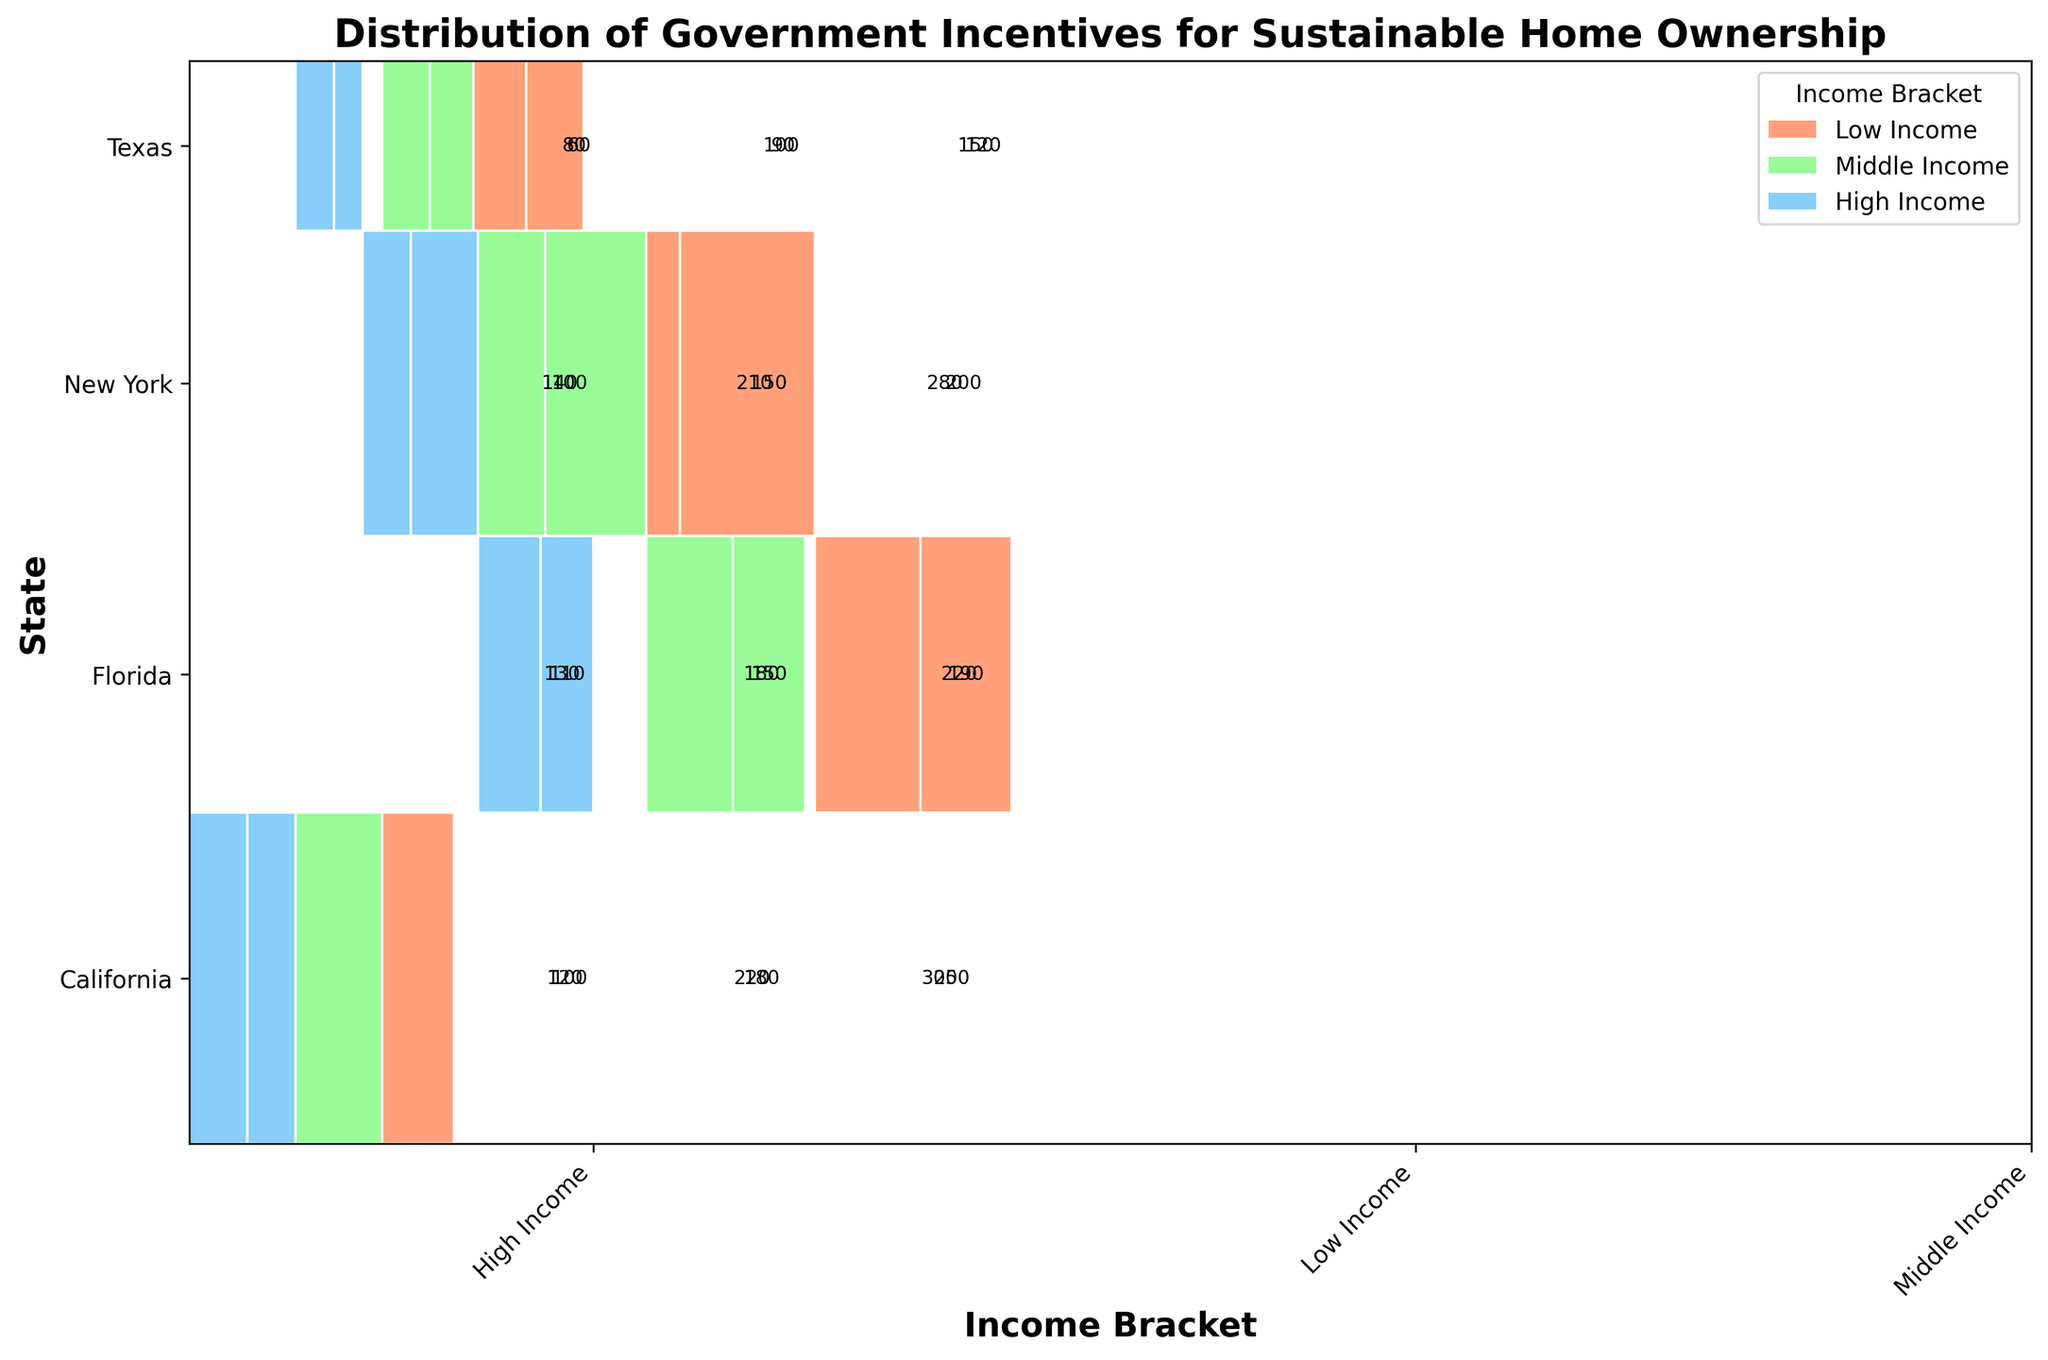What is the title of the plot? The title is typically located at the top of the plot. It is designed to give a brief description of what the chart represents.
Answer: Distribution of Government Incentives for Sustainable Home Ownership Which state has the highest total count of incentives? Look at the y-axis labels and find the state with the largest overall area. California's section is the highest.
Answer: California Which income bracket receives the most incentives in New York? Within New York's section on the plot, locate the largest area corresponding to each income bracket.
Answer: Low Income How does the count of Solar Tax Credits for Low Income in California compare to Middle Income in California? Observe the size of the rectangles within California's section for each income bracket. The Low Income section has a larger area than the Middle Income section.
Answer: Higher for Low Income What's the total count of incentives for Low Income in Texas? Sum the counts for Wind Power Rebate and Geothermal Incentive under Low Income in Texas. 150 + 120.
Answer: 270 Do Low Income households in Florida receive more or less Water Conservation Rebates than High Income households? Compare the areas of the rectangles representing Low Income and High Income within Florida's section for Water Conservation Rebates.
Answer: More Which state has the least diversity in incentive types? Check for a state with the fewest different colors (representing unique incentive types): Texas has only two types.
Answer: Texas How many types of incentives are provided to Middle Income earners in New York? Identify all the color rectangles within New York under the Middle Income label. There are two types: Green Roof Subsidy and Energy Star Appliance Rebate.
Answer: 2 What is the overall visual appearance of High Income incentives compared to Low Income incentives across all states? Notice the relative areas: High Income areas are generally smaller compared to Low Income areas.
Answer: Smaller 